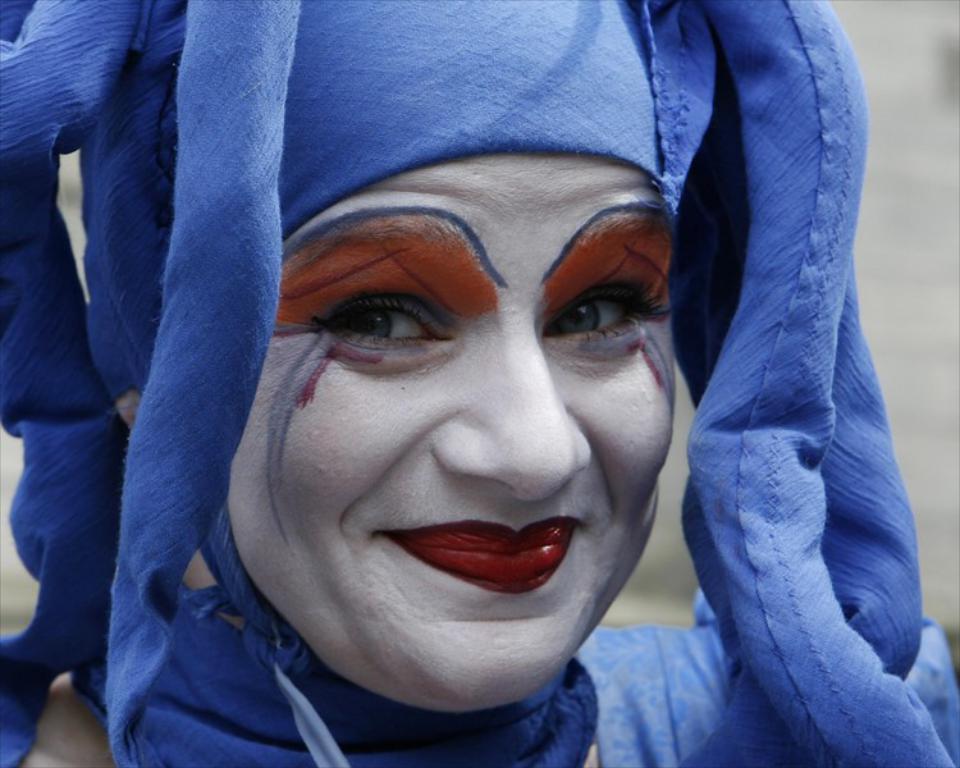How would you summarize this image in a sentence or two? In this picture we can see a person is smiling in the front, this person is wearing costume, there is a blurry background. 